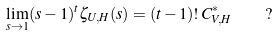<formula> <loc_0><loc_0><loc_500><loc_500>\lim _ { s \to 1 } ( s - 1 ) ^ { t } \zeta _ { U , H } ( s ) = ( t - 1 ) ! \, C ^ { \ast } _ { V , H } \quad ?</formula> 